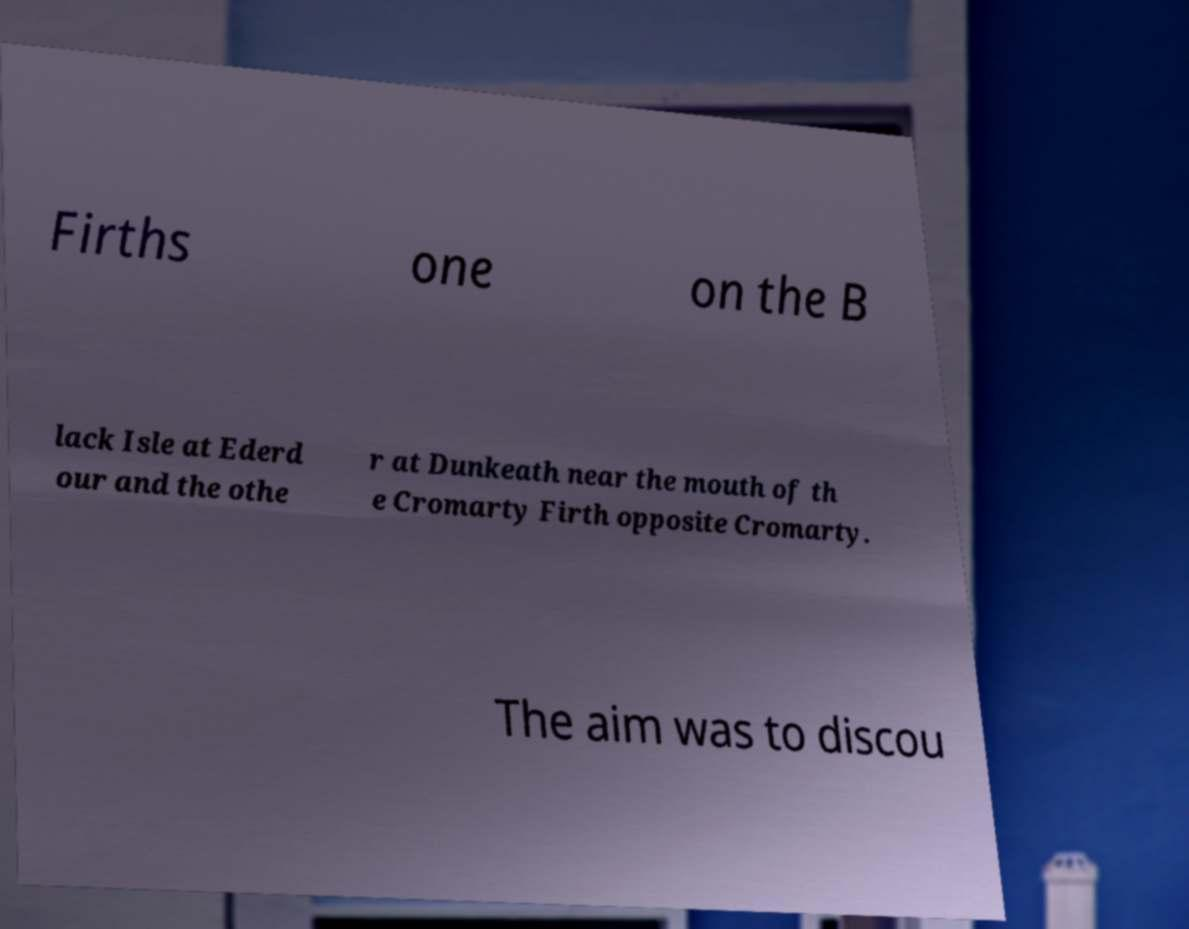Please identify and transcribe the text found in this image. Firths one on the B lack Isle at Ederd our and the othe r at Dunkeath near the mouth of th e Cromarty Firth opposite Cromarty. The aim was to discou 